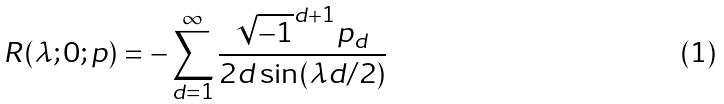Convert formula to latex. <formula><loc_0><loc_0><loc_500><loc_500>R ( \lambda ; 0 ; p ) = - \sum _ { d = 1 } ^ { \infty } \frac { \sqrt { - 1 } ^ { d + 1 } p _ { d } } { 2 d \sin ( \lambda d / 2 ) }</formula> 